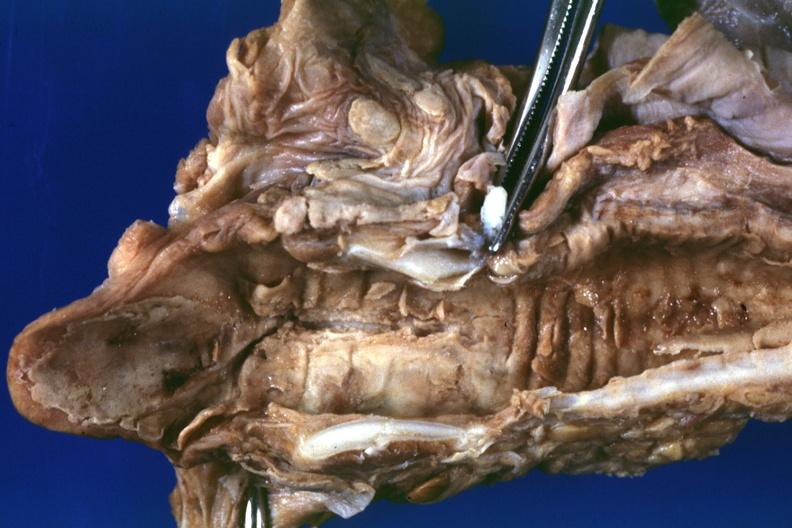s herpes simplex present?
Answer the question using a single word or phrase. Yes 